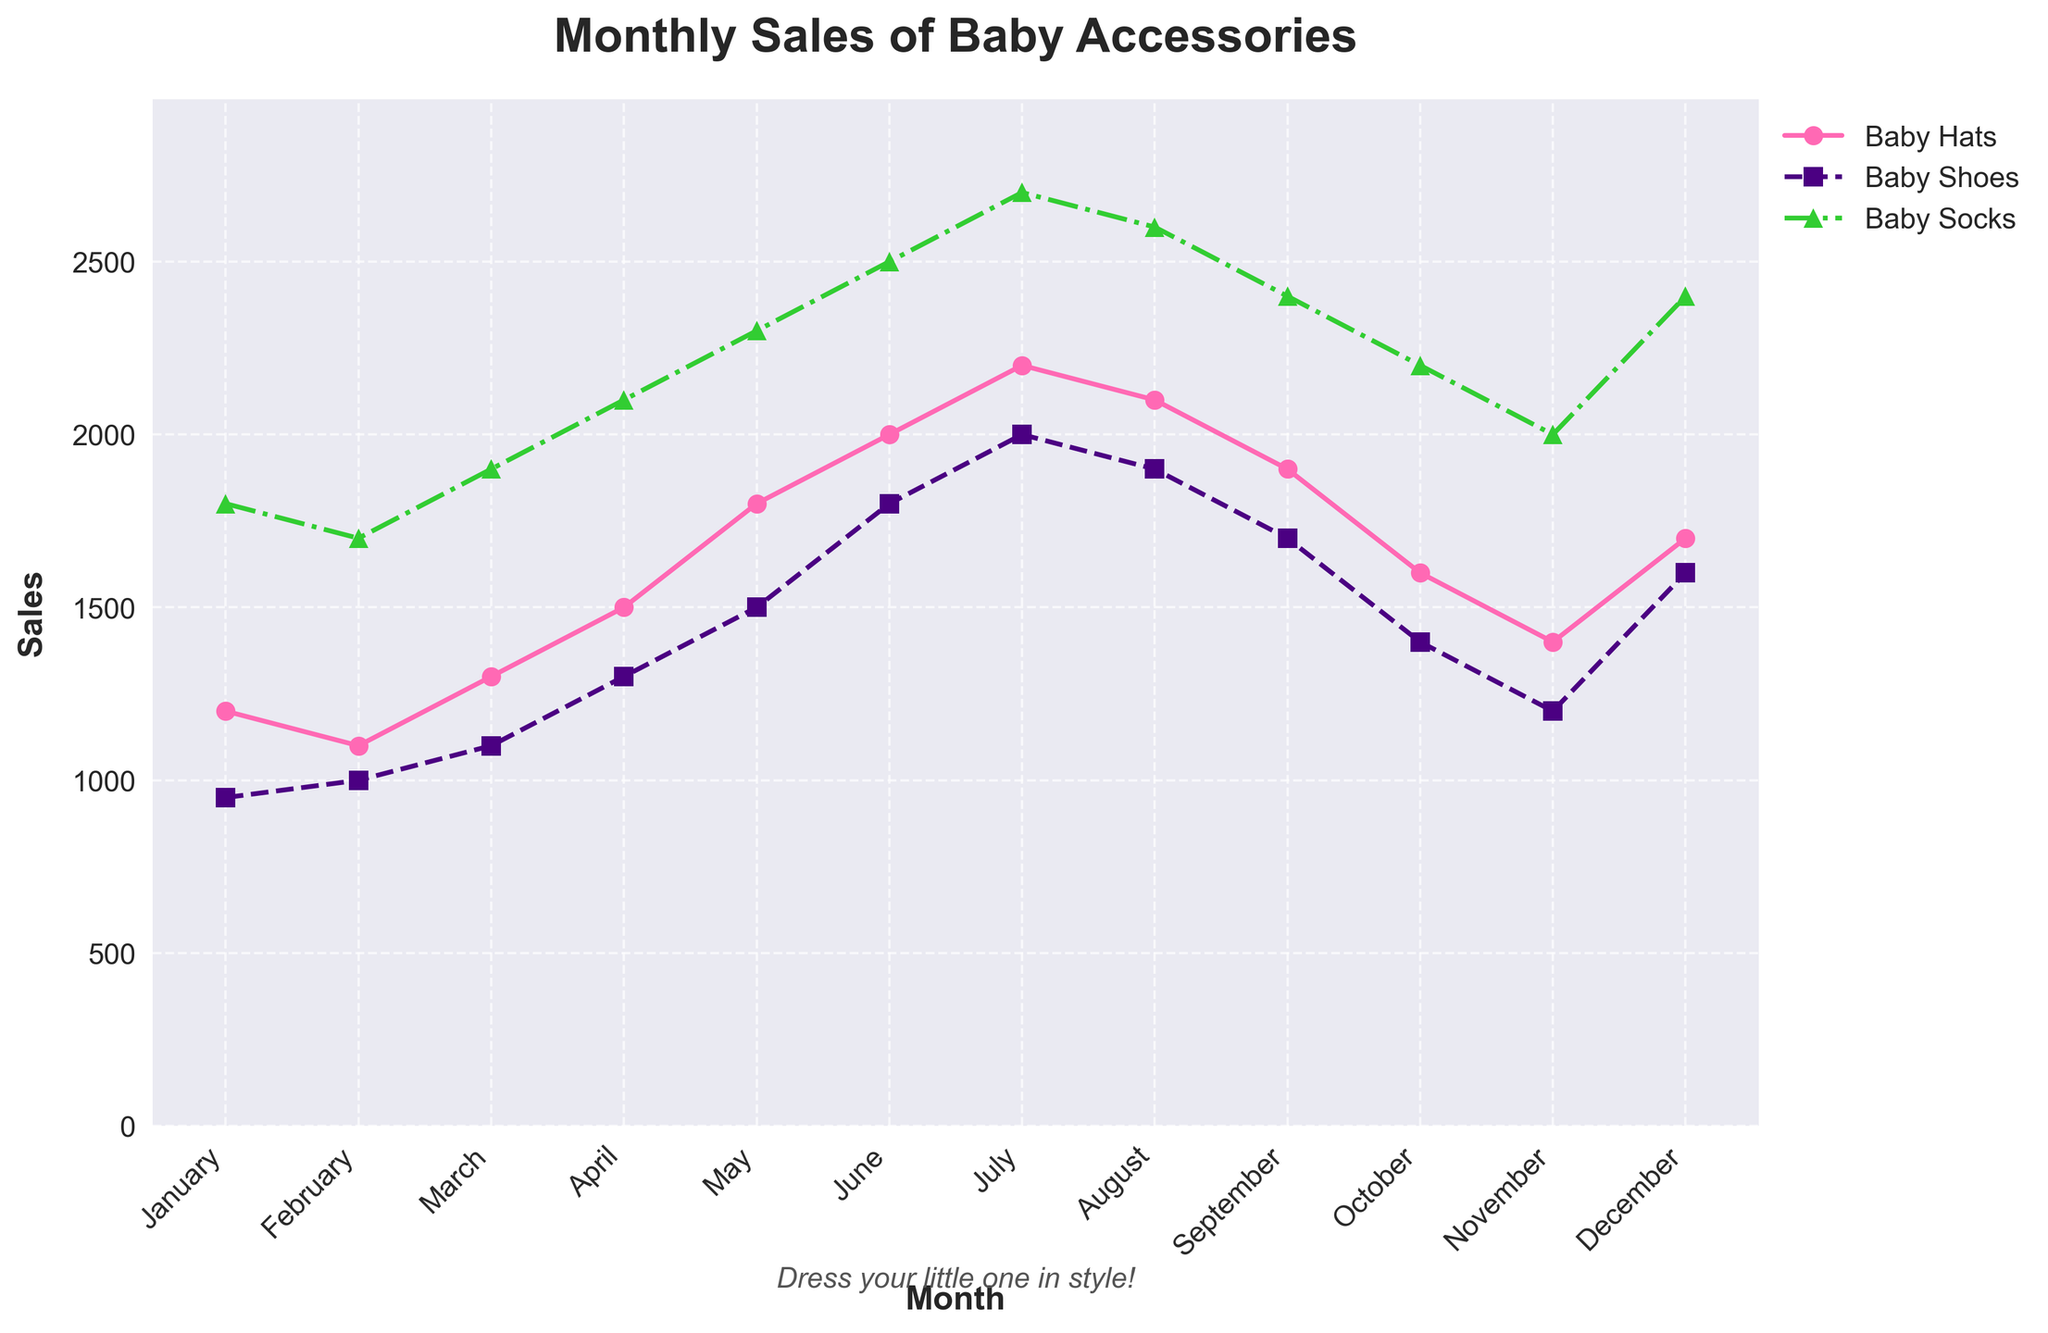What's the highest monthly sales figure for Baby Socks? To find the highest sales figure for Baby Socks, look for the peak point in the green (Baby Socks) line on the chart: it occurs in July with a value of 2700.
Answer: 2700 Which month shows the lowest sales for Baby Shoes? To find the lowest sales, observe the purple (Baby Shoes) line and locate the minimum point. The lowest sales occur in January with a value of 950.
Answer: January How do the sales of Baby Hats in March compare to those in May? Compare the two points on the pink (Baby Hats) line for March and May. March has sales of 1300 and May has sales of 1800. Since 1800 is greater than 1300, sales are higher in May.
Answer: Higher in May What is the average monthly sales for Baby Hats in the first half of the year? First, sum the sales from January to June: 1200 + 1100 + 1300 + 1500 + 1800 + 2000 = 8900. Then, divide by 6 to find the average: 8900 / 6 ≈ 1483.33.
Answer: 1483.33 How much higher are the sales of Baby Socks in June compared to February? Compare February (1700) and June (2500) values on the green (Baby Socks) line. The difference is 2500 - 1700 = 800.
Answer: 800 In which months do Baby Hats have higher sales than Baby Shoes? Identify the pink and purple lines and compare values for each month:
- January: 1200 > 950
- February: 1100 > 1000
- March: 1300 > 1100
- April: 1500 > 1300
- May: 1800 > 1500
- June: 2000 > 1800
- July: 2200 > 2000
- August: 2100 > 1900
- September: 1900 > 1700
- October: 1600 > 1400
- November: 1400 > 1200
- December: 1700 > 1600
Baby Hats have higher sales in all months.
Answer: All months During which month do all three accessories (Hats, Shoes, Socks) have the highest combined sales? Sum the values for each accessory per month and identify the maximum combined sales value. The highest occurs in July: 2200 (Hats) + 2000 (Shoes) + 2700 (Socks) = 6900.
Answer: July When the sales increment from one month to the next is maximum, is it for Baby Hats, Baby Shoes, or Baby Socks, and what is its value? To determine this, calculate the month-over-month differences for each accessory:
- Baby Hats: maximum jump is from April (1500) to May (1800), a difference of 300.
- Baby Shoes: maximum jump is from May (1500) to June (1800), also a difference of 300.
- Baby Socks: maximum jump is from May (2300) to June (2500), a difference of 200.
Hence, the maximum increment of 300 is shared by Baby Hats and Baby Shoes.
Answer: Baby Hats and Baby Shoes, 300 What is the trend observed for Baby Hats throughout the year? Observing the pink (Baby Hats) line, we see an increasing trend from January (1200) to July (2200), then a decreasing trend from August (2100) to October (1600), with a slight rise again in December (1700).
Answer: Increasing then decreasing 